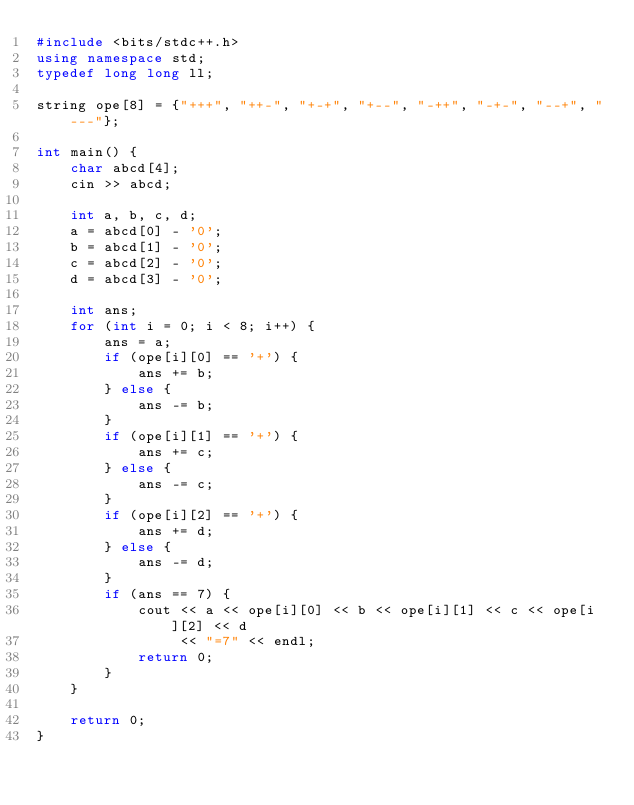<code> <loc_0><loc_0><loc_500><loc_500><_C++_>#include <bits/stdc++.h>
using namespace std;
typedef long long ll;

string ope[8] = {"+++", "++-", "+-+", "+--", "-++", "-+-", "--+", "---"};

int main() {
    char abcd[4];
    cin >> abcd;

    int a, b, c, d;
    a = abcd[0] - '0';
    b = abcd[1] - '0';
    c = abcd[2] - '0';
    d = abcd[3] - '0';

    int ans;
    for (int i = 0; i < 8; i++) {
        ans = a;
        if (ope[i][0] == '+') {
            ans += b;
        } else {
            ans -= b;
        }
        if (ope[i][1] == '+') {
            ans += c;
        } else {
            ans -= c;
        }
        if (ope[i][2] == '+') {
            ans += d;
        } else {
            ans -= d;
        }
        if (ans == 7) {
            cout << a << ope[i][0] << b << ope[i][1] << c << ope[i][2] << d
                 << "=7" << endl;
            return 0;
        }
    }

    return 0;
}</code> 